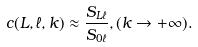<formula> <loc_0><loc_0><loc_500><loc_500>c ( L , \ell , k ) \approx \frac { S _ { L \ell } } { S _ { 0 \ell } } , ( k \rightarrow + \infty ) .</formula> 